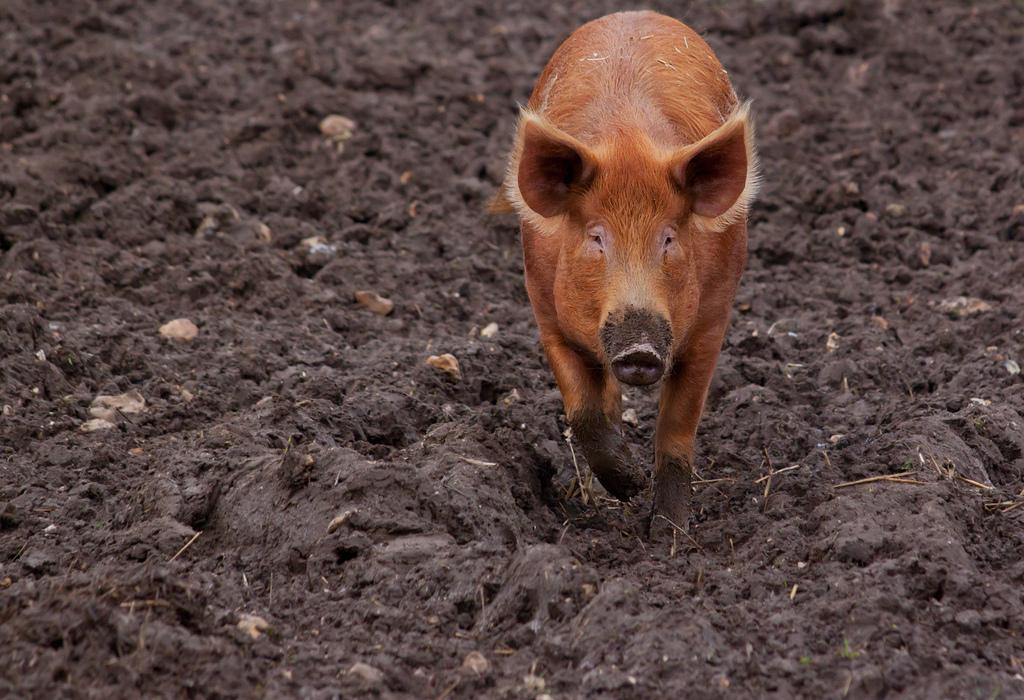What animal is present in the image? There is a pig in the image. What color is the pig? The pig is brown in color. What substance is visible in the image? There is mud in the image. What type of creature is using its tongue to write a message in the mud? There is no creature using its tongue to write a message in the mud in the image. 